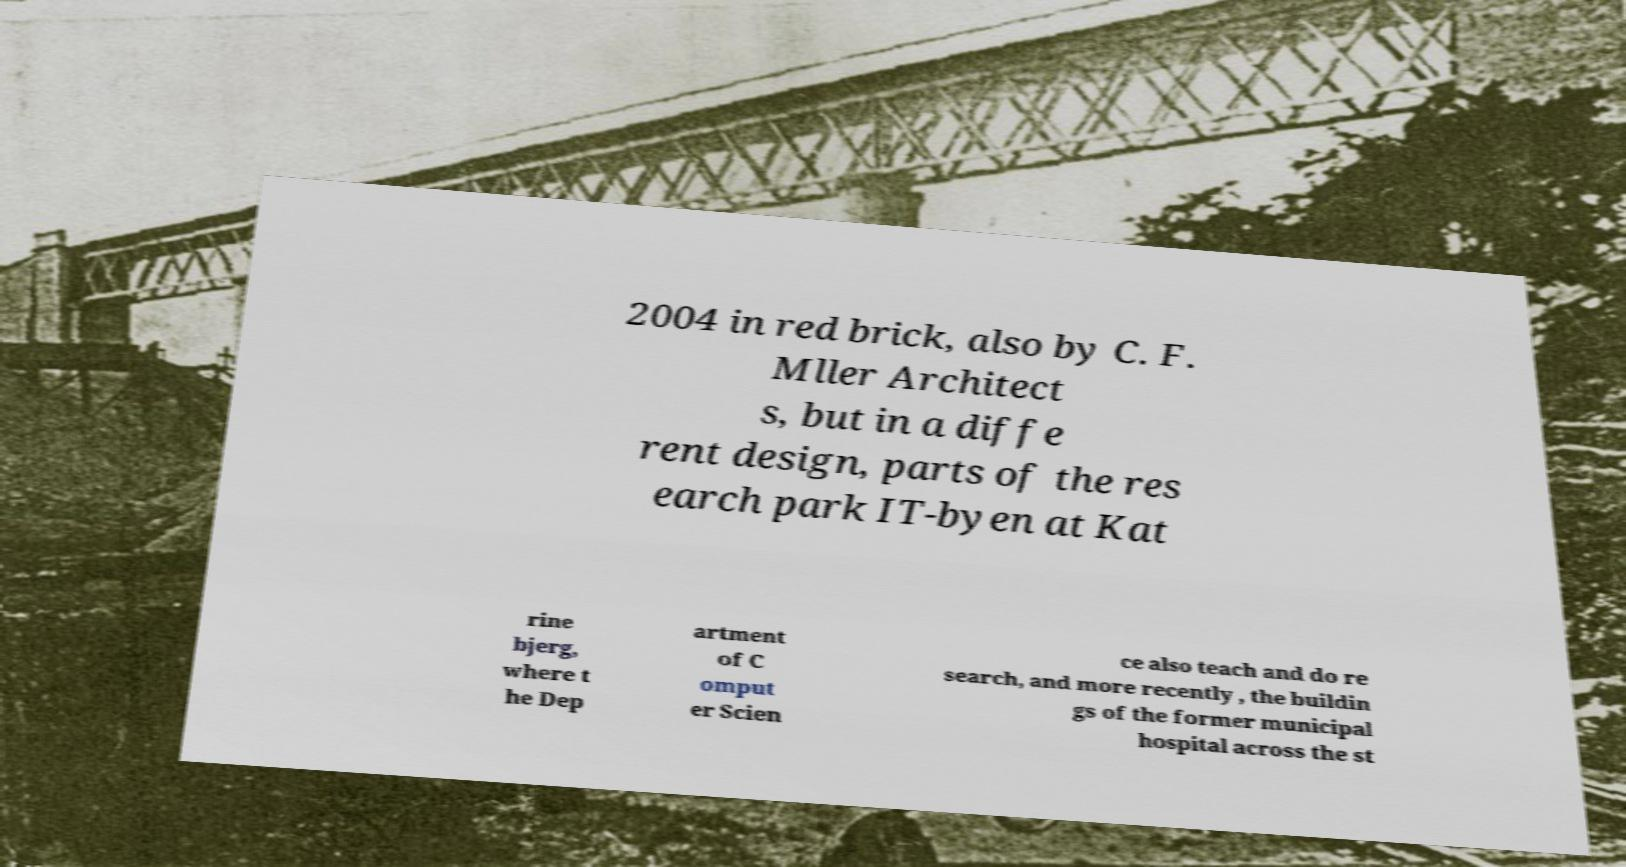Please identify and transcribe the text found in this image. 2004 in red brick, also by C. F. Mller Architect s, but in a diffe rent design, parts of the res earch park IT-byen at Kat rine bjerg, where t he Dep artment of C omput er Scien ce also teach and do re search, and more recently , the buildin gs of the former municipal hospital across the st 